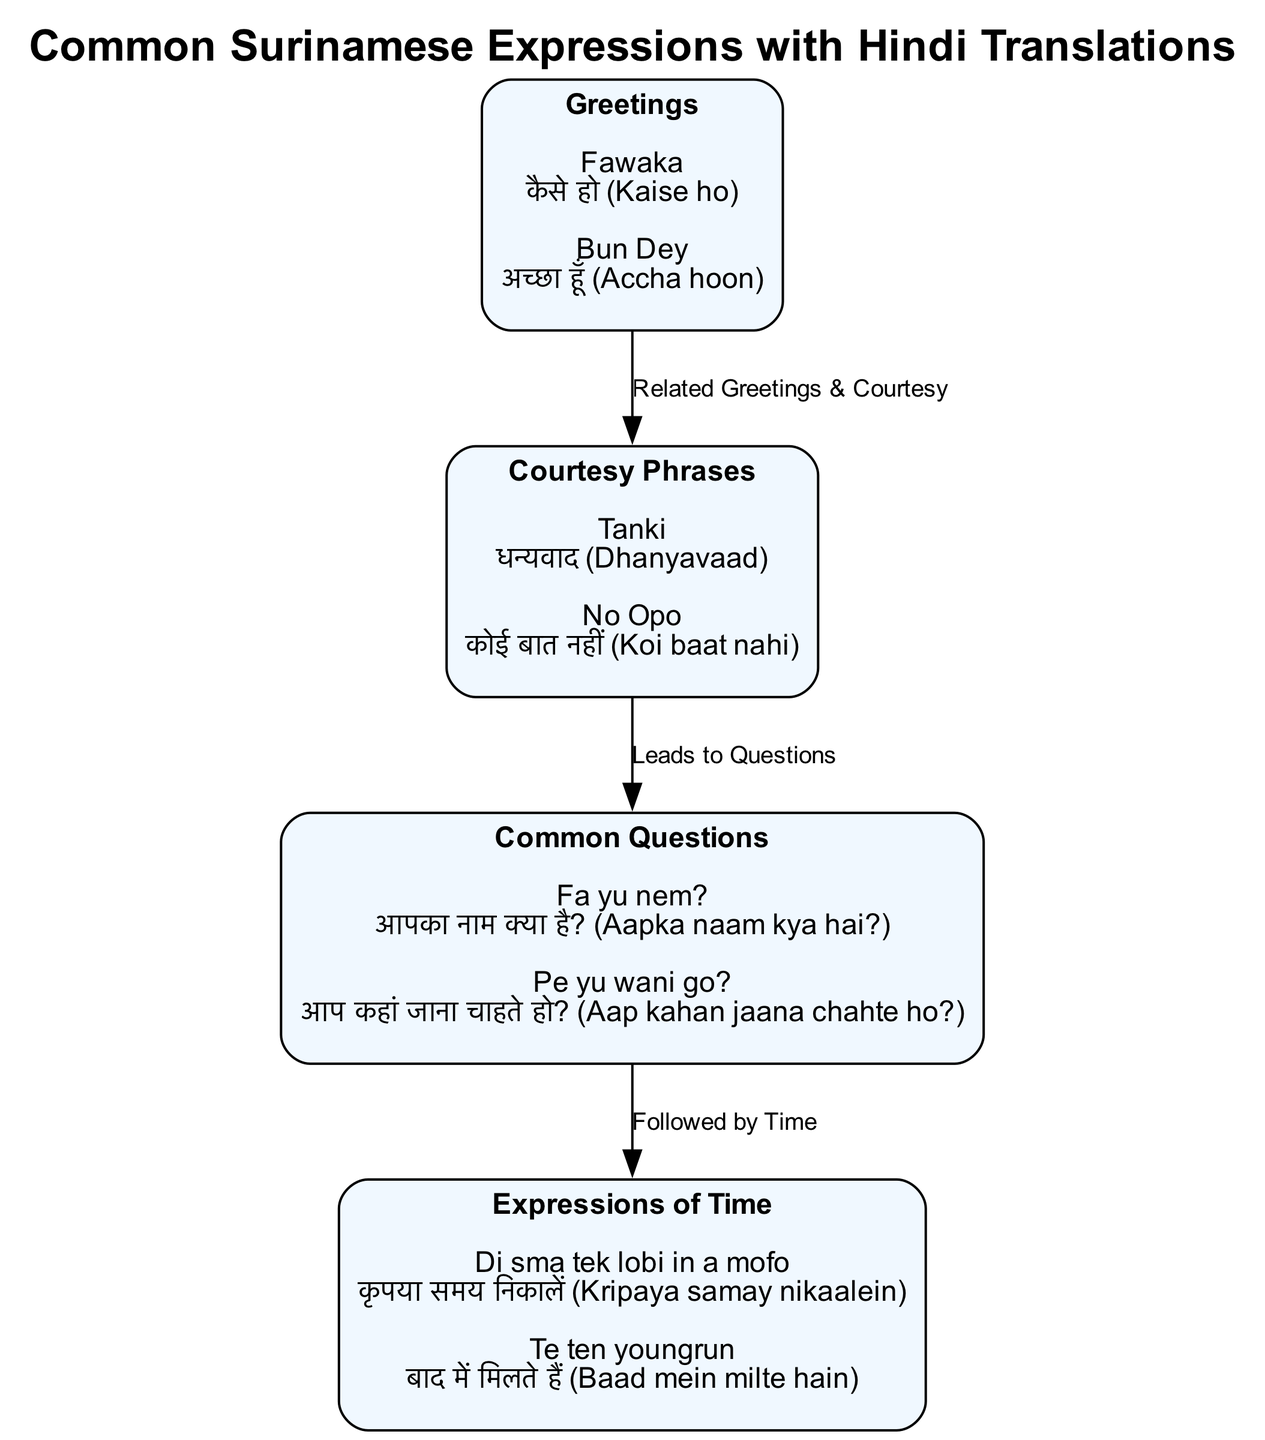What are the two categories listed in the diagram? The diagram includes two categories labeled "Greetings" and "Courtesy Phrases." These can be identified as the initial nodes in the diagram, each containing Surinamese expressions and their Hindi translations.
Answer: Greetings, Courtesy Phrases How many nodes are present in the diagram? In the diagram, there are a total of four nodes: "Greetings," "Courtesy Phrases," "Common Questions," and "Expressions of Time." After counting each distinct category represented in the diagram, we can confirm the total.
Answer: 4 What Surinamese expression translates to "आपका नाम क्या है?" To find the corresponding Surinamese expression, we look at the "Common Questions" node. There, we see that "Fa yu nem?" translates to "आपका नाम क्या है?" according to the expressions listed.
Answer: Fa yu nem? Which node leads to "Common Questions"? The connection flow in the diagram shows that "Courtesy Phrases" leads to "Common Questions." This is evidenced by the directed edge connecting these two nodes, indicating a progression from one to the next.
Answer: Courtesy Phrases What is the Hindi translation for "Tanki"? By reviewing the "Courtesy Phrases" node, we can find that "Tanki" translates to "धन्यवाद (Dhanyavaad)." This is one of the expressions provided under that category in the diagram.
Answer: धन्यवाद (Dhanyavaad) How are "Greetings" and "Courtesy Phrases" related? The diagram identifies a relationship labeled "Related Greetings & Courtesy" between the nodes "Greetings" and "Courtesy Phrases." This suggests that they share a thematic connection in the expressions used.
Answer: Related Greetings & Courtesy What is the relationship between "Common Questions" and "Expressions of Time"? The relationship is labeled "Followed by Time," which indicates that after asking questions, one might naturally transition to discussing expressions related to time. This relationship is visualized by an edge connecting these two nodes.
Answer: Followed by Time 